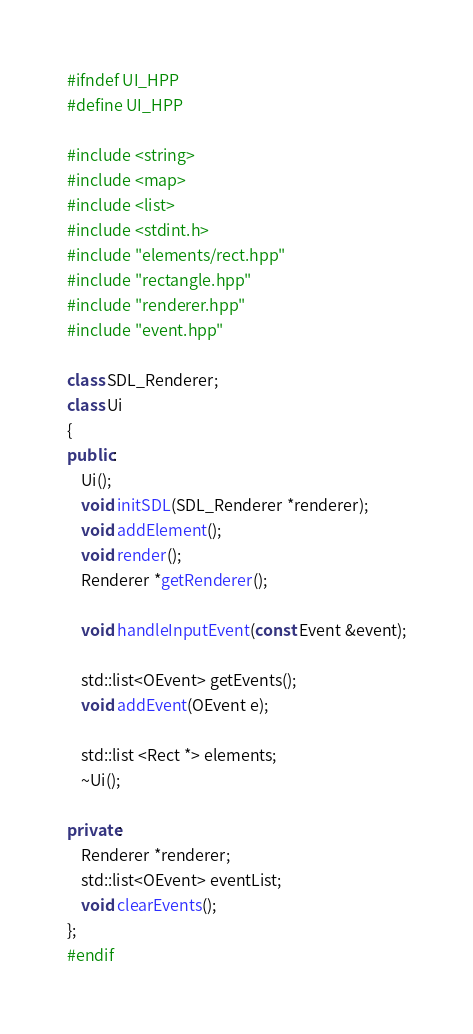Convert code to text. <code><loc_0><loc_0><loc_500><loc_500><_C++_>#ifndef UI_HPP
#define UI_HPP

#include <string>
#include <map>
#include <list>
#include <stdint.h>
#include "elements/rect.hpp"
#include "rectangle.hpp"
#include "renderer.hpp"
#include "event.hpp"

class SDL_Renderer;
class Ui
{
public:
    Ui();
    void initSDL(SDL_Renderer *renderer);
    void addElement();
    void render();
    Renderer *getRenderer();

    void handleInputEvent(const Event &event);

    std::list<OEvent> getEvents();
    void addEvent(OEvent e);

    std::list <Rect *> elements;
    ~Ui();

private:
    Renderer *renderer;
    std::list<OEvent> eventList;
    void clearEvents();
};
#endif
</code> 